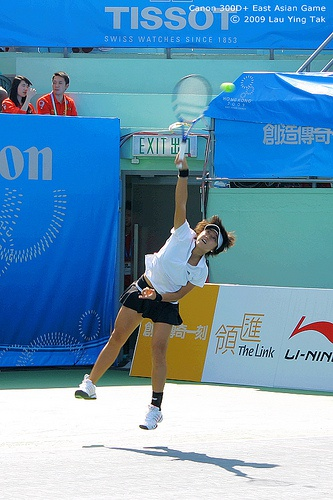Describe the objects in this image and their specific colors. I can see people in gray, black, and lightblue tones, tennis racket in gray, lightblue, and teal tones, people in gray, brown, and maroon tones, people in gray, black, and brown tones, and sports ball in gray, beige, and lightgreen tones in this image. 